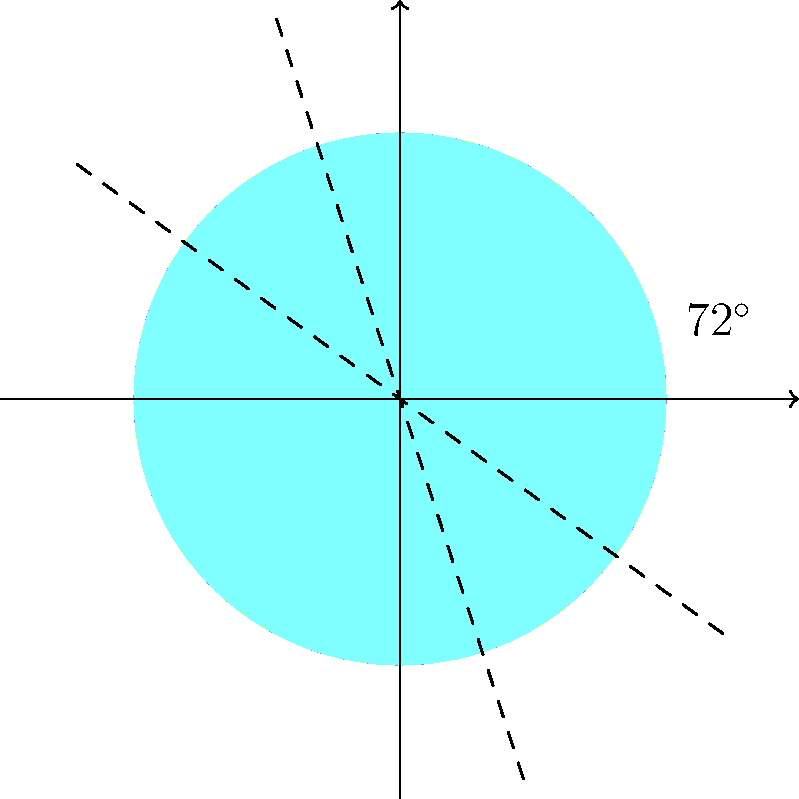A circular coral reef formation exhibits rotational symmetry of order 5 and reflection symmetry across 5 axes, as shown in the diagram. What is the symmetry group of this coral reef formation, and how many elements does it contain? To determine the symmetry group and its order, let's analyze the symmetries step-by-step:

1. Rotational symmetry:
   - The coral reef has 5-fold rotational symmetry (order 5).
   - This includes rotations by 0°, 72°, 144°, 216°, and 288°.
   - There are 5 rotational symmetries.

2. Reflection symmetry:
   - There are 5 reflection axes, as shown by the dashed lines in the diagram.
   - Each reflection is a unique symmetry operation.
   - There are 5 reflection symmetries.

3. Symmetry group identification:
   - The combination of n-fold rotational symmetry and n reflection axes characterizes the dihedral group $D_n$.
   - In this case, we have $D_5$ (dihedral group of order 5).

4. Number of elements in the group:
   - The order of a dihedral group $D_n$ is given by the formula: $|D_n| = 2n$
   - For $D_5$, we have: $|D_5| = 2 \times 5 = 10$

Therefore, the symmetry group of this coral reef formation is the dihedral group $D_5$, which contains 10 elements (5 rotations and 5 reflections).
Answer: $D_5$, 10 elements 